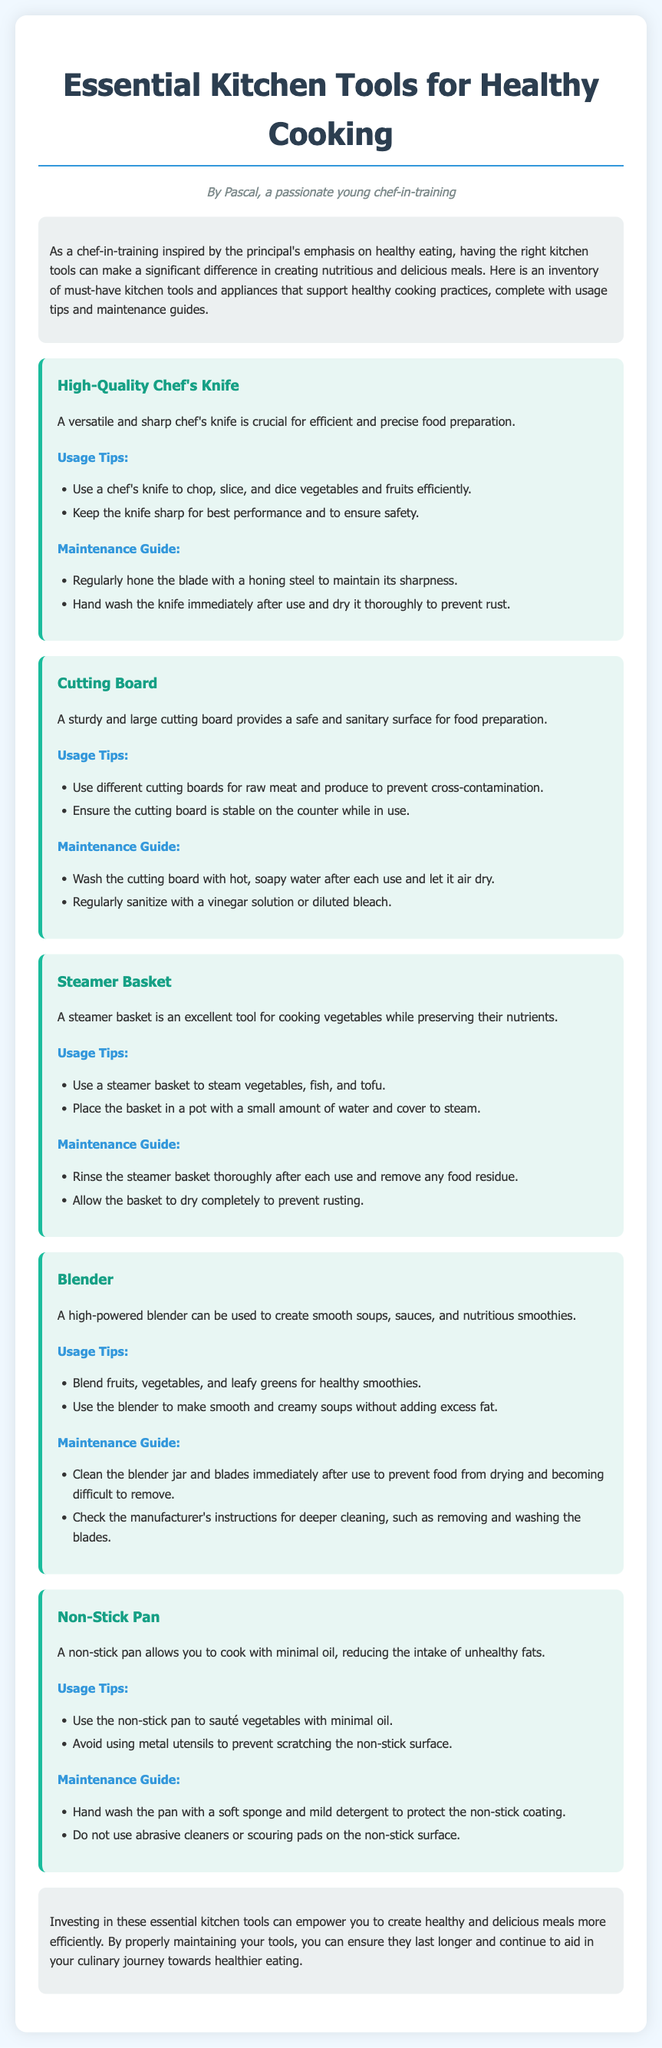What is the title of the document? The title of the document is the main heading at the top, which summarizes the content.
Answer: Essential Kitchen Tools for Healthy Cooking Who is the author of this document? The author is mentioned at the beginning of the document, indicating who created it.
Answer: Pascal What is recommended for maintaining a chef's knife? The maintenance section for the chef's knife includes specific tasks to keep it in good condition.
Answer: Hand wash the knife immediately after use and dry it thoroughly to prevent rust Which kitchen tool is described as useful for cooking without losing nutrients? The tool mentioned in the document that helps with nutrient preservation is specifically highlighted in one section.
Answer: Steamer Basket How should you clean a non-stick pan? The document details specific cleaning practices needed to maintain the non-stick surface of the pan.
Answer: Hand wash the pan with a soft sponge and mild detergent What type of board is suggested for preventing cross-contamination? The type of board that is mentioned in the document that helps avoid food safety issues is discussed in its respective section.
Answer: Cutting Board How can you use a blender to create healthy meals? The document lists specific uses of the blender that align with healthy cooking practices.
Answer: Blend fruits, vegetables, and leafy greens for healthy smoothies What is a key benefit of a non-stick pan mentioned in the document? The document mentions a specific advantage of using a non-stick pan related to health in its description.
Answer: Reducing the intake of unhealthy fats What should you do after using a steamer basket? The maintenance guide for the steamer basket provides specific instructions after its use.
Answer: Rinse the steamer basket thoroughly after each use and remove any food residue 